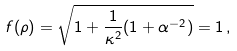<formula> <loc_0><loc_0><loc_500><loc_500>f ( \rho ) = \sqrt { 1 + \frac { 1 } { \kappa ^ { 2 } } ( 1 + \alpha ^ { - 2 } ) } = 1 \, ,</formula> 